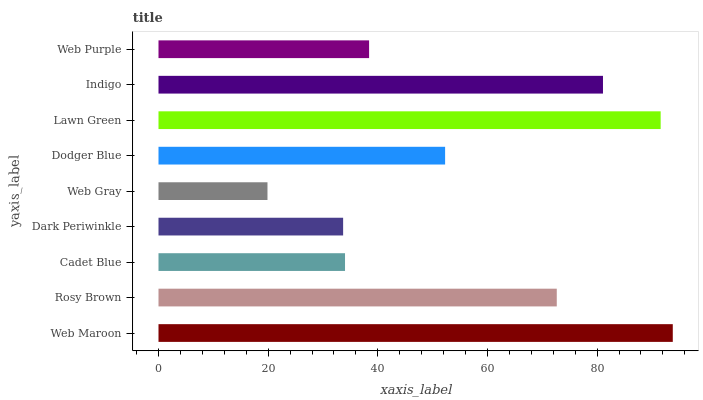Is Web Gray the minimum?
Answer yes or no. Yes. Is Web Maroon the maximum?
Answer yes or no. Yes. Is Rosy Brown the minimum?
Answer yes or no. No. Is Rosy Brown the maximum?
Answer yes or no. No. Is Web Maroon greater than Rosy Brown?
Answer yes or no. Yes. Is Rosy Brown less than Web Maroon?
Answer yes or no. Yes. Is Rosy Brown greater than Web Maroon?
Answer yes or no. No. Is Web Maroon less than Rosy Brown?
Answer yes or no. No. Is Dodger Blue the high median?
Answer yes or no. Yes. Is Dodger Blue the low median?
Answer yes or no. Yes. Is Indigo the high median?
Answer yes or no. No. Is Web Gray the low median?
Answer yes or no. No. 